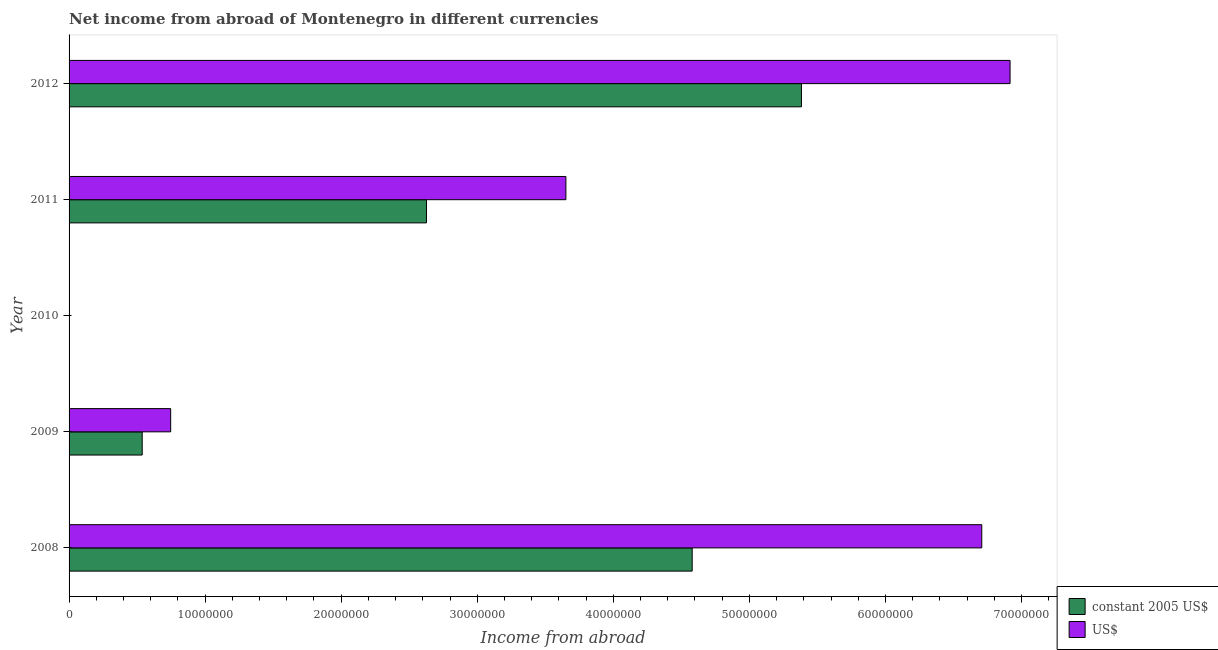Are the number of bars per tick equal to the number of legend labels?
Make the answer very short. No. Are the number of bars on each tick of the Y-axis equal?
Provide a short and direct response. No. How many bars are there on the 5th tick from the top?
Provide a succinct answer. 2. How many bars are there on the 3rd tick from the bottom?
Make the answer very short. 0. What is the label of the 5th group of bars from the top?
Your answer should be compact. 2008. Across all years, what is the maximum income from abroad in us$?
Offer a terse response. 6.92e+07. Across all years, what is the minimum income from abroad in constant 2005 us$?
Your response must be concise. 0. In which year was the income from abroad in us$ maximum?
Ensure brevity in your answer.  2012. What is the total income from abroad in constant 2005 us$ in the graph?
Offer a very short reply. 1.31e+08. What is the difference between the income from abroad in constant 2005 us$ in 2008 and that in 2012?
Make the answer very short. -8.03e+06. What is the difference between the income from abroad in us$ in 2008 and the income from abroad in constant 2005 us$ in 2011?
Give a very brief answer. 4.08e+07. What is the average income from abroad in constant 2005 us$ per year?
Keep it short and to the point. 2.63e+07. In the year 2009, what is the difference between the income from abroad in us$ and income from abroad in constant 2005 us$?
Your response must be concise. 2.09e+06. In how many years, is the income from abroad in constant 2005 us$ greater than 24000000 units?
Offer a very short reply. 3. What is the ratio of the income from abroad in constant 2005 us$ in 2008 to that in 2012?
Provide a short and direct response. 0.85. Is the income from abroad in us$ in 2009 less than that in 2012?
Your response must be concise. Yes. Is the difference between the income from abroad in constant 2005 us$ in 2009 and 2011 greater than the difference between the income from abroad in us$ in 2009 and 2011?
Your answer should be very brief. Yes. What is the difference between the highest and the second highest income from abroad in constant 2005 us$?
Offer a terse response. 8.03e+06. What is the difference between the highest and the lowest income from abroad in us$?
Make the answer very short. 6.92e+07. Is the sum of the income from abroad in constant 2005 us$ in 2009 and 2011 greater than the maximum income from abroad in us$ across all years?
Your answer should be compact. No. How many bars are there?
Make the answer very short. 8. How many years are there in the graph?
Ensure brevity in your answer.  5. What is the difference between two consecutive major ticks on the X-axis?
Give a very brief answer. 1.00e+07. Does the graph contain grids?
Offer a very short reply. No. How many legend labels are there?
Offer a very short reply. 2. What is the title of the graph?
Ensure brevity in your answer.  Net income from abroad of Montenegro in different currencies. What is the label or title of the X-axis?
Provide a short and direct response. Income from abroad. What is the label or title of the Y-axis?
Offer a terse response. Year. What is the Income from abroad in constant 2005 US$ in 2008?
Ensure brevity in your answer.  4.58e+07. What is the Income from abroad in US$ in 2008?
Make the answer very short. 6.71e+07. What is the Income from abroad in constant 2005 US$ in 2009?
Your answer should be compact. 5.38e+06. What is the Income from abroad in US$ in 2009?
Your answer should be very brief. 7.47e+06. What is the Income from abroad of US$ in 2010?
Offer a very short reply. 0. What is the Income from abroad in constant 2005 US$ in 2011?
Offer a very short reply. 2.63e+07. What is the Income from abroad of US$ in 2011?
Offer a terse response. 3.65e+07. What is the Income from abroad of constant 2005 US$ in 2012?
Offer a terse response. 5.38e+07. What is the Income from abroad in US$ in 2012?
Your answer should be very brief. 6.92e+07. Across all years, what is the maximum Income from abroad of constant 2005 US$?
Your answer should be compact. 5.38e+07. Across all years, what is the maximum Income from abroad in US$?
Offer a terse response. 6.92e+07. Across all years, what is the minimum Income from abroad of constant 2005 US$?
Your answer should be very brief. 0. What is the total Income from abroad in constant 2005 US$ in the graph?
Provide a succinct answer. 1.31e+08. What is the total Income from abroad of US$ in the graph?
Ensure brevity in your answer.  1.80e+08. What is the difference between the Income from abroad of constant 2005 US$ in 2008 and that in 2009?
Offer a terse response. 4.04e+07. What is the difference between the Income from abroad of US$ in 2008 and that in 2009?
Keep it short and to the point. 5.96e+07. What is the difference between the Income from abroad of constant 2005 US$ in 2008 and that in 2011?
Provide a succinct answer. 1.95e+07. What is the difference between the Income from abroad in US$ in 2008 and that in 2011?
Provide a succinct answer. 3.06e+07. What is the difference between the Income from abroad in constant 2005 US$ in 2008 and that in 2012?
Give a very brief answer. -8.03e+06. What is the difference between the Income from abroad of US$ in 2008 and that in 2012?
Give a very brief answer. -2.08e+06. What is the difference between the Income from abroad in constant 2005 US$ in 2009 and that in 2011?
Ensure brevity in your answer.  -2.09e+07. What is the difference between the Income from abroad of US$ in 2009 and that in 2011?
Your answer should be compact. -2.90e+07. What is the difference between the Income from abroad in constant 2005 US$ in 2009 and that in 2012?
Give a very brief answer. -4.85e+07. What is the difference between the Income from abroad in US$ in 2009 and that in 2012?
Offer a very short reply. -6.17e+07. What is the difference between the Income from abroad in constant 2005 US$ in 2011 and that in 2012?
Give a very brief answer. -2.76e+07. What is the difference between the Income from abroad in US$ in 2011 and that in 2012?
Provide a short and direct response. -3.26e+07. What is the difference between the Income from abroad of constant 2005 US$ in 2008 and the Income from abroad of US$ in 2009?
Make the answer very short. 3.83e+07. What is the difference between the Income from abroad in constant 2005 US$ in 2008 and the Income from abroad in US$ in 2011?
Your response must be concise. 9.28e+06. What is the difference between the Income from abroad of constant 2005 US$ in 2008 and the Income from abroad of US$ in 2012?
Give a very brief answer. -2.34e+07. What is the difference between the Income from abroad of constant 2005 US$ in 2009 and the Income from abroad of US$ in 2011?
Your response must be concise. -3.11e+07. What is the difference between the Income from abroad in constant 2005 US$ in 2009 and the Income from abroad in US$ in 2012?
Ensure brevity in your answer.  -6.38e+07. What is the difference between the Income from abroad of constant 2005 US$ in 2011 and the Income from abroad of US$ in 2012?
Make the answer very short. -4.29e+07. What is the average Income from abroad of constant 2005 US$ per year?
Give a very brief answer. 2.63e+07. What is the average Income from abroad in US$ per year?
Offer a terse response. 3.60e+07. In the year 2008, what is the difference between the Income from abroad of constant 2005 US$ and Income from abroad of US$?
Give a very brief answer. -2.13e+07. In the year 2009, what is the difference between the Income from abroad of constant 2005 US$ and Income from abroad of US$?
Your response must be concise. -2.09e+06. In the year 2011, what is the difference between the Income from abroad in constant 2005 US$ and Income from abroad in US$?
Offer a very short reply. -1.02e+07. In the year 2012, what is the difference between the Income from abroad in constant 2005 US$ and Income from abroad in US$?
Give a very brief answer. -1.53e+07. What is the ratio of the Income from abroad of constant 2005 US$ in 2008 to that in 2009?
Keep it short and to the point. 8.52. What is the ratio of the Income from abroad in US$ in 2008 to that in 2009?
Make the answer very short. 8.98. What is the ratio of the Income from abroad of constant 2005 US$ in 2008 to that in 2011?
Provide a short and direct response. 1.74. What is the ratio of the Income from abroad in US$ in 2008 to that in 2011?
Make the answer very short. 1.84. What is the ratio of the Income from abroad in constant 2005 US$ in 2008 to that in 2012?
Your answer should be very brief. 0.85. What is the ratio of the Income from abroad of US$ in 2008 to that in 2012?
Offer a very short reply. 0.97. What is the ratio of the Income from abroad in constant 2005 US$ in 2009 to that in 2011?
Offer a very short reply. 0.2. What is the ratio of the Income from abroad of US$ in 2009 to that in 2011?
Keep it short and to the point. 0.2. What is the ratio of the Income from abroad of constant 2005 US$ in 2009 to that in 2012?
Provide a succinct answer. 0.1. What is the ratio of the Income from abroad in US$ in 2009 to that in 2012?
Give a very brief answer. 0.11. What is the ratio of the Income from abroad in constant 2005 US$ in 2011 to that in 2012?
Give a very brief answer. 0.49. What is the ratio of the Income from abroad of US$ in 2011 to that in 2012?
Provide a succinct answer. 0.53. What is the difference between the highest and the second highest Income from abroad of constant 2005 US$?
Your answer should be very brief. 8.03e+06. What is the difference between the highest and the second highest Income from abroad in US$?
Give a very brief answer. 2.08e+06. What is the difference between the highest and the lowest Income from abroad in constant 2005 US$?
Your answer should be very brief. 5.38e+07. What is the difference between the highest and the lowest Income from abroad of US$?
Ensure brevity in your answer.  6.92e+07. 